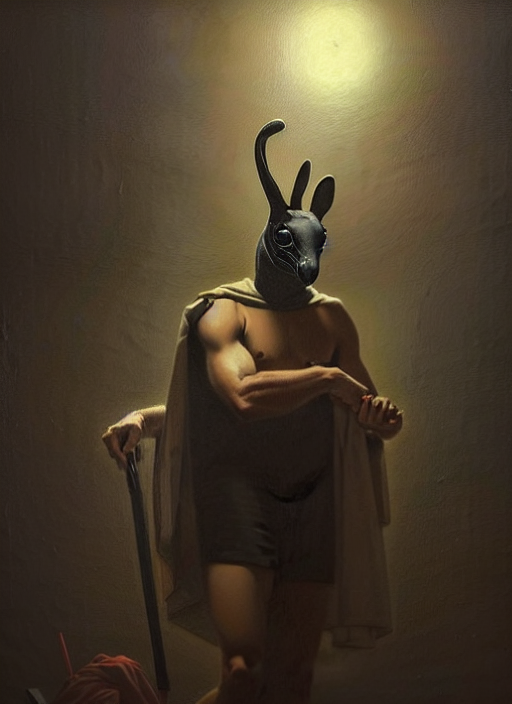What is the atmosphere or mood conveyed by this image? The image presents a powerful and somewhat enigmatic mood. The character, donning an animal mask, stands confidently yet portrays a sense of mystery and anticipation. The warm, focused lighting creates an intense aura around the figure, enhancing the dramatic effect. 